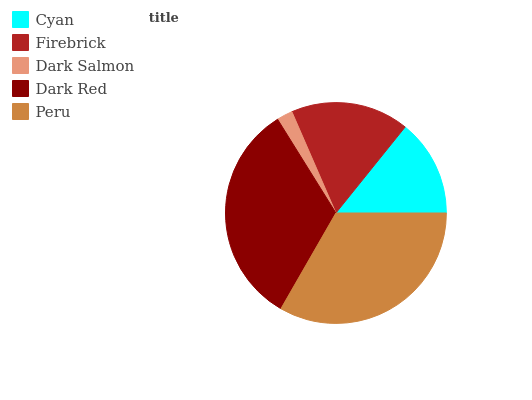Is Dark Salmon the minimum?
Answer yes or no. Yes. Is Peru the maximum?
Answer yes or no. Yes. Is Firebrick the minimum?
Answer yes or no. No. Is Firebrick the maximum?
Answer yes or no. No. Is Firebrick greater than Cyan?
Answer yes or no. Yes. Is Cyan less than Firebrick?
Answer yes or no. Yes. Is Cyan greater than Firebrick?
Answer yes or no. No. Is Firebrick less than Cyan?
Answer yes or no. No. Is Firebrick the high median?
Answer yes or no. Yes. Is Firebrick the low median?
Answer yes or no. Yes. Is Cyan the high median?
Answer yes or no. No. Is Cyan the low median?
Answer yes or no. No. 